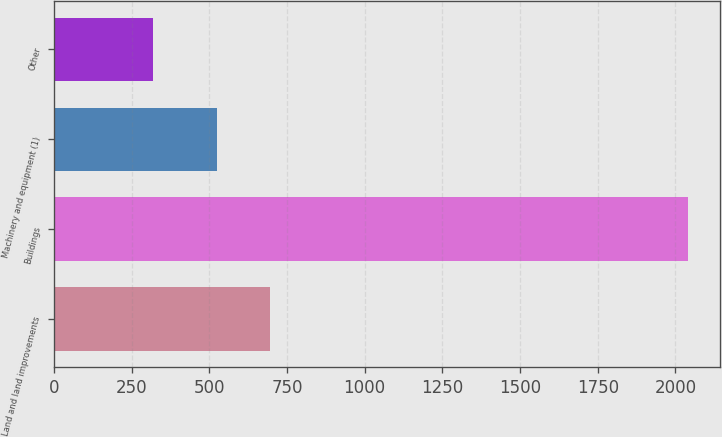<chart> <loc_0><loc_0><loc_500><loc_500><bar_chart><fcel>Land and land improvements<fcel>Buildings<fcel>Machinery and equipment (1)<fcel>Other<nl><fcel>697<fcel>2040<fcel>525<fcel>320<nl></chart> 